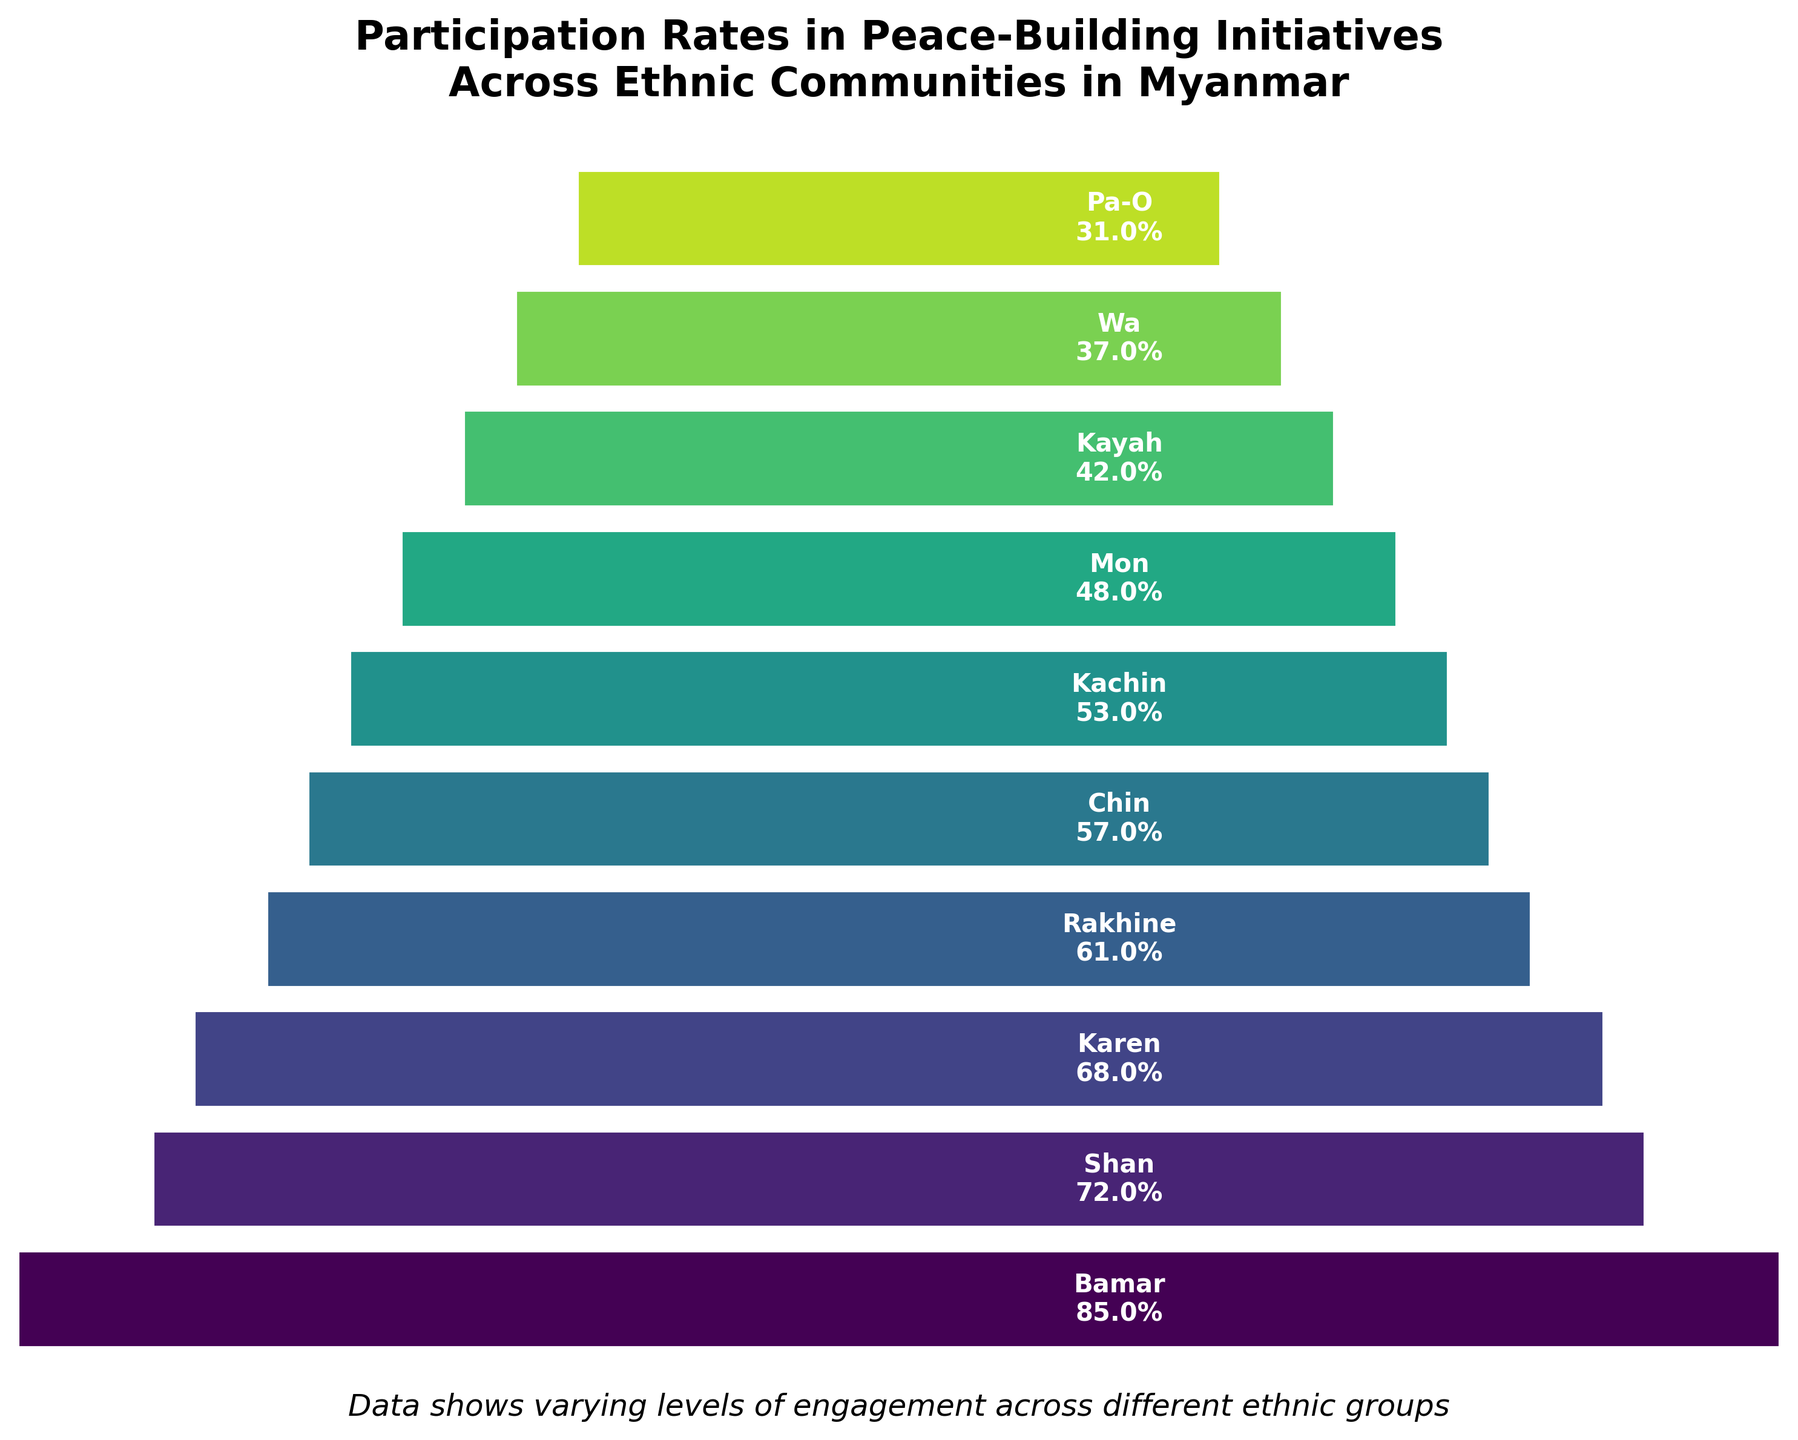what is the title of the chart? The title is usually located at the top of the chart and serves to describe what the chart represents. The title of this chart is “Participation Rates in Peace-Building Initiatives Across Ethnic Communities in Myanmar”.
Answer: Participation Rates in Peace-Building Initiatives Across Ethnic Communities in Myanmar which ethnic group has the highest participation rate? The ethnic group with the highest participation rate is displayed at the widest part of the funnel, which is at the top. The figure shows Bamar at the top with the highest participation rate of 85%.
Answer: Bamar how many ethnic groups are shown in the figure? To determine the number of ethnic groups, count the number of distinct segments in the funnel chart. Each segment corresponds to an ethnic group. There are 10 segments displayed in the chart.
Answer: 10 which ethnic group has the lowest participation rate? The ethnic group with the lowest participation rate is displayed at the narrowest part of the funnel, which is at the bottom. The figure shows Pa-O at the bottom with the lowest participation rate of 31%.
Answer: Pa-O what is the participation rate of the Karen ethnic group? Locate the segment labeled ‘Karen’ in the funnel chart and read the participation rate displayed within or close to the segment. The chart shows that the participation rate for the Karen ethnic group is 68%.
Answer: 68% what is the difference in participation rates between the Shan and Rakhine ethnic groups? To find the difference, subtract the participation rate of Rakhine from that of Shan. According to the figure, the participation rate for Shan is 72% and for Rakhine is 61%. The difference is 72% - 61% = 11%.
Answer: 11% which ethnic groups have participation rates above 50%? Identify all segments in the funnel chart with participation rates greater than 50%. According to the chart, the ethnic groups with rates above 50% are Bamar (85%), Shan (72%), Karen (68%), Rakhine (61%), Chin (57%), and Kachin (53%).
Answer: Bamar, Shan, Karen, Rakhine, Chin, Kachin what is the median participation rate among all the ethnic groups? To calculate the median, arrange the participation rates in ascending or descending order and find the middle value. The rates in ascending order are: 31, 37, 42, 48, 53, 57, 61, 68, 72, 85. The median is the average of the 5th and 6th values since there are 10 data points: (53 + 57) / 2 = 55%.
Answer: 55% which ethnic group has a participation rate closest to the median value? First, find the median participation rate, which is 55%. Then, locate the ethnic group's participation rate that is closest to this value. According to the figure, Kachin has a participation rate of 53%, which is the closest to 55%.
Answer: Kachin 